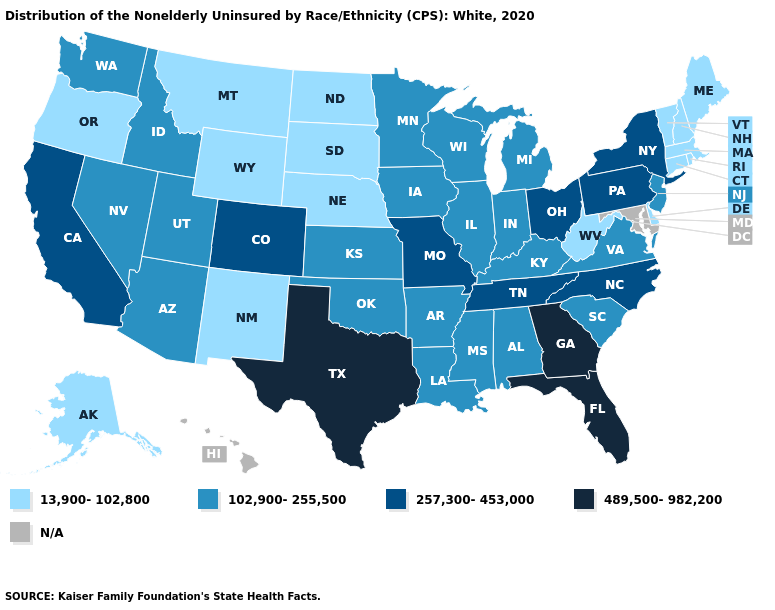Name the states that have a value in the range 13,900-102,800?
Concise answer only. Alaska, Connecticut, Delaware, Maine, Massachusetts, Montana, Nebraska, New Hampshire, New Mexico, North Dakota, Oregon, Rhode Island, South Dakota, Vermont, West Virginia, Wyoming. What is the value of Texas?
Answer briefly. 489,500-982,200. What is the value of Vermont?
Give a very brief answer. 13,900-102,800. Name the states that have a value in the range 13,900-102,800?
Answer briefly. Alaska, Connecticut, Delaware, Maine, Massachusetts, Montana, Nebraska, New Hampshire, New Mexico, North Dakota, Oregon, Rhode Island, South Dakota, Vermont, West Virginia, Wyoming. Name the states that have a value in the range N/A?
Give a very brief answer. Hawaii, Maryland. What is the lowest value in the South?
Write a very short answer. 13,900-102,800. What is the highest value in states that border Illinois?
Concise answer only. 257,300-453,000. Among the states that border Montana , which have the highest value?
Answer briefly. Idaho. Name the states that have a value in the range N/A?
Write a very short answer. Hawaii, Maryland. Name the states that have a value in the range 489,500-982,200?
Concise answer only. Florida, Georgia, Texas. Is the legend a continuous bar?
Keep it brief. No. Does Idaho have the highest value in the USA?
Concise answer only. No. What is the lowest value in states that border Wisconsin?
Answer briefly. 102,900-255,500. 